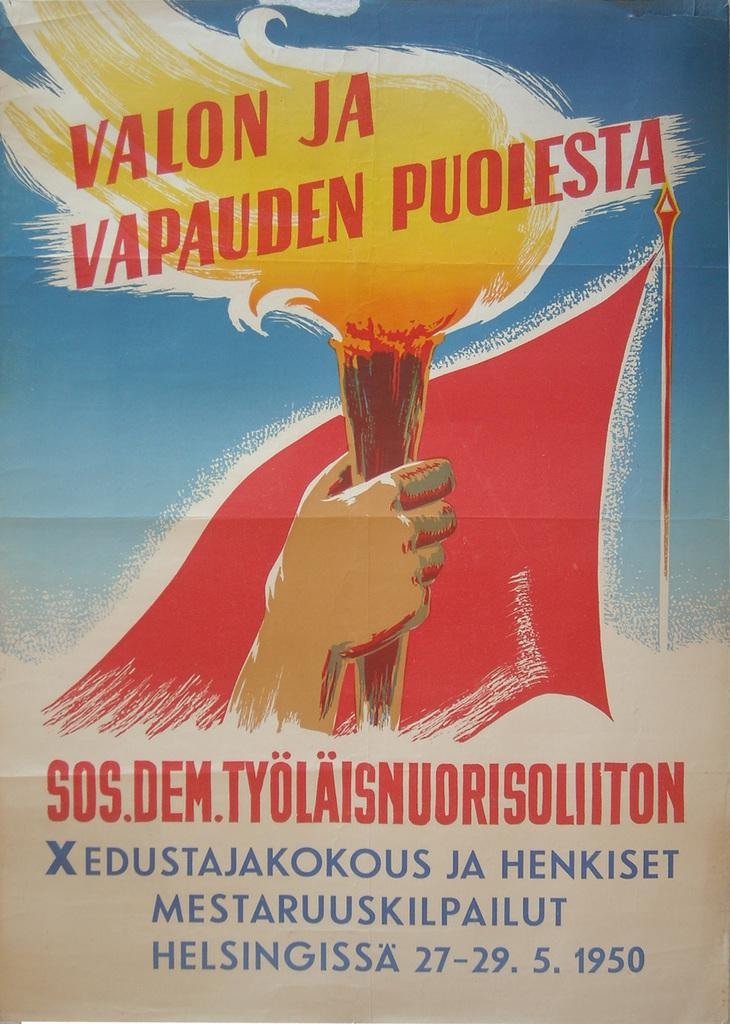<image>
Describe the image concisely. An ad displays a year of 1950 and has a picture of a torch on it. 